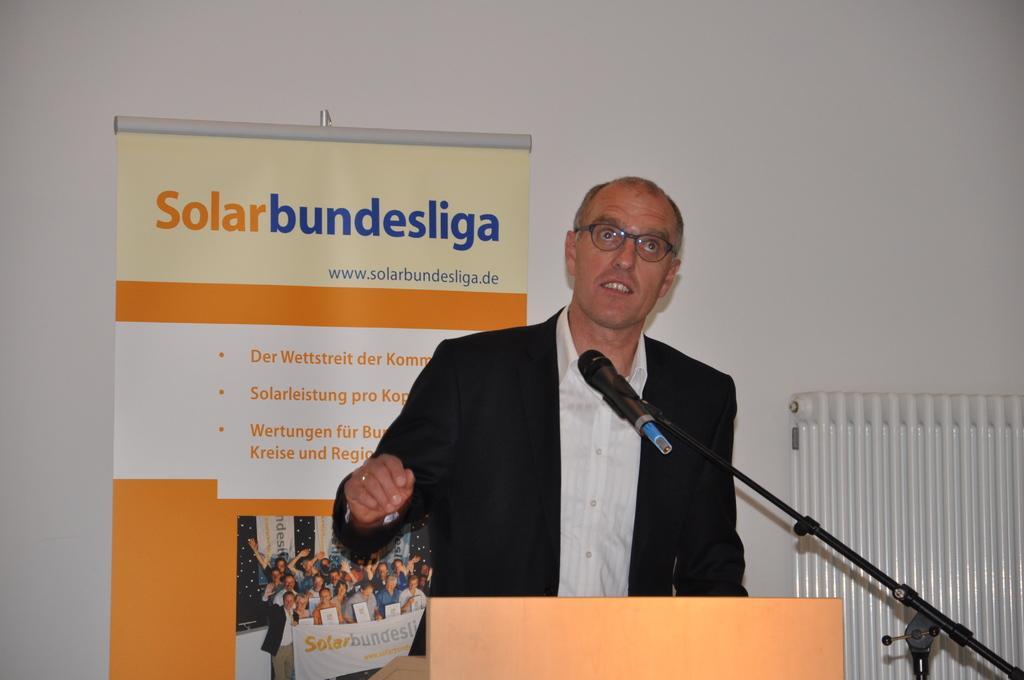Can you describe this image briefly? In this picture there is a man who is standing near to the speech desk and mic. Behind him there is a banner which is placed near to the wall. In that banner I can see the group of persons who are holding a banner and standing near to the wall. On the right I can see some white object. 